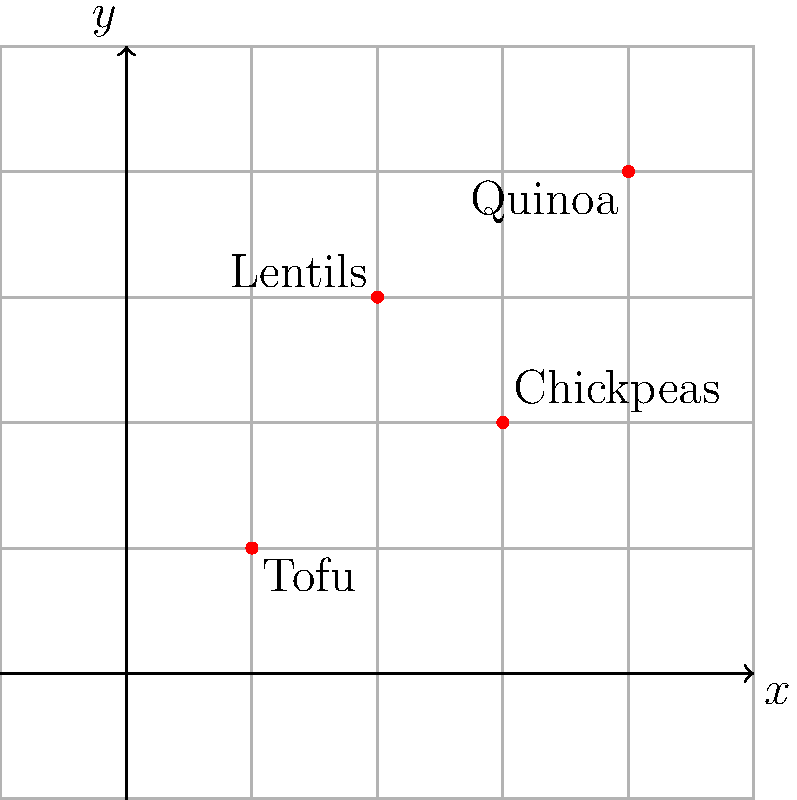As a newly converted vegetarian exploring plant-based protein sources, you're given a grid representing different options. If you were to translate all points on this grid 2 units to the right and 1 unit down, what would be the new coordinates of Lentils? To solve this problem, we need to follow these steps:

1. Identify the original coordinates of Lentils:
   The original point for Lentils is at (2, 3).

2. Apply the translation:
   - Moving 2 units to the right means adding 2 to the x-coordinate.
   - Moving 1 unit down means subtracting 1 from the y-coordinate.

3. Calculate the new coordinates:
   - New x-coordinate: $2 + 2 = 4$
   - New y-coordinate: $3 - 1 = 2$

4. Express the new point as an ordered pair:
   The new coordinates for Lentils after translation are (4, 2).

This translation would apply to all points on the grid, shifting the entire plant-based protein map. It's a useful way to visualize how different protein sources relate to each other in terms of nutritional content or cooking versatility.
Answer: (4, 2) 